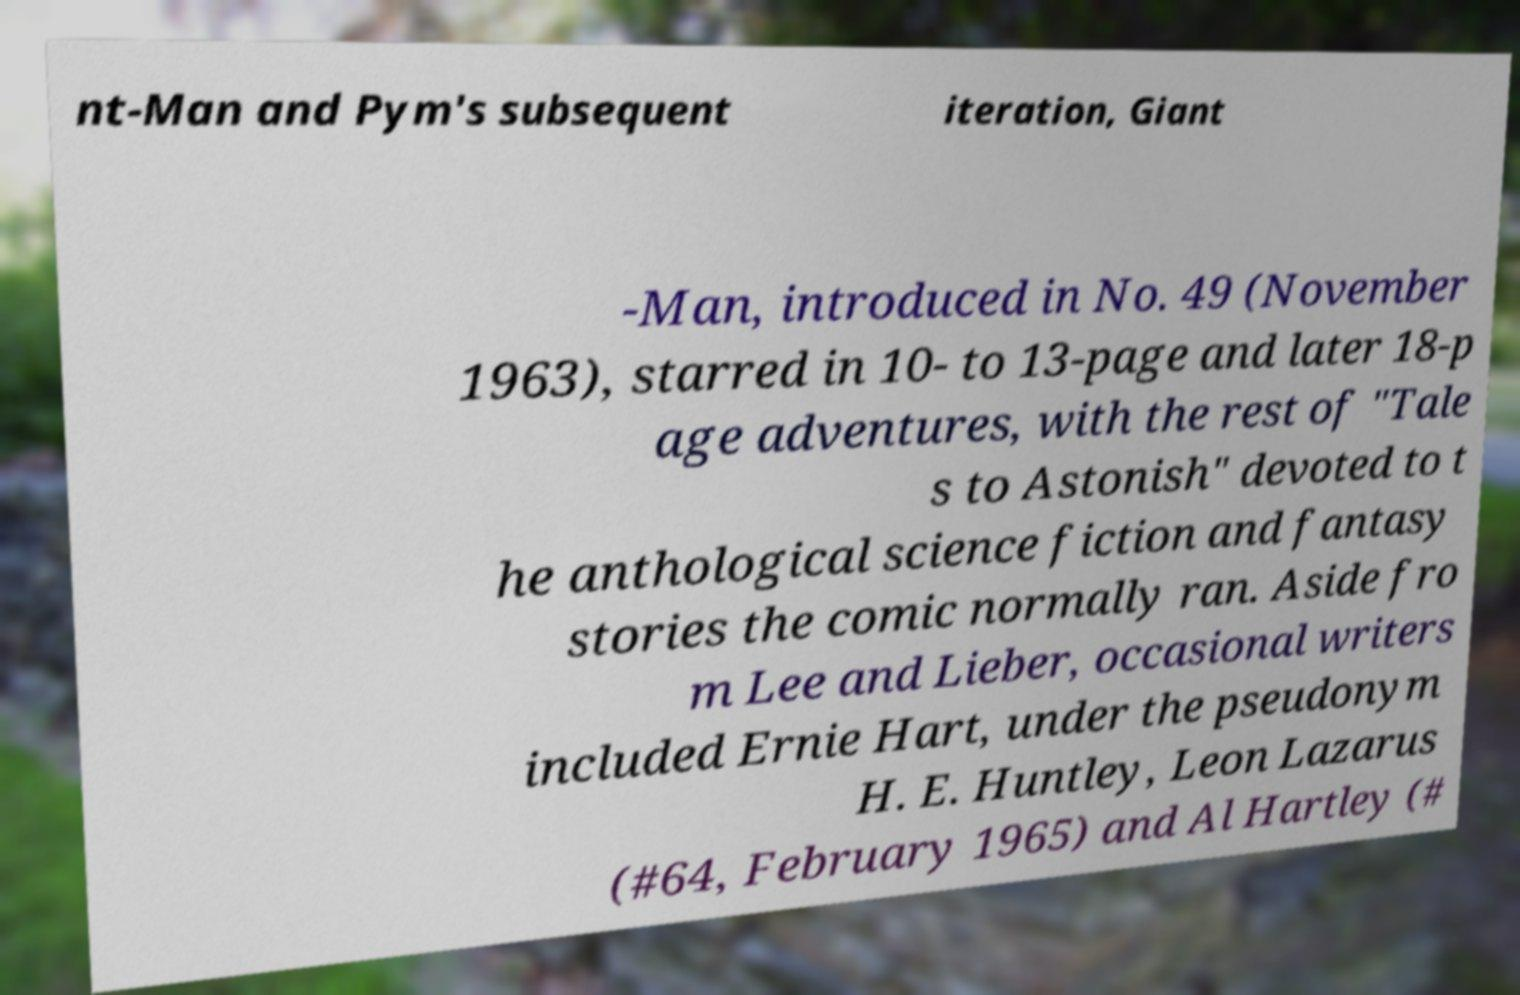For documentation purposes, I need the text within this image transcribed. Could you provide that? nt-Man and Pym's subsequent iteration, Giant -Man, introduced in No. 49 (November 1963), starred in 10- to 13-page and later 18-p age adventures, with the rest of "Tale s to Astonish" devoted to t he anthological science fiction and fantasy stories the comic normally ran. Aside fro m Lee and Lieber, occasional writers included Ernie Hart, under the pseudonym H. E. Huntley, Leon Lazarus (#64, February 1965) and Al Hartley (# 